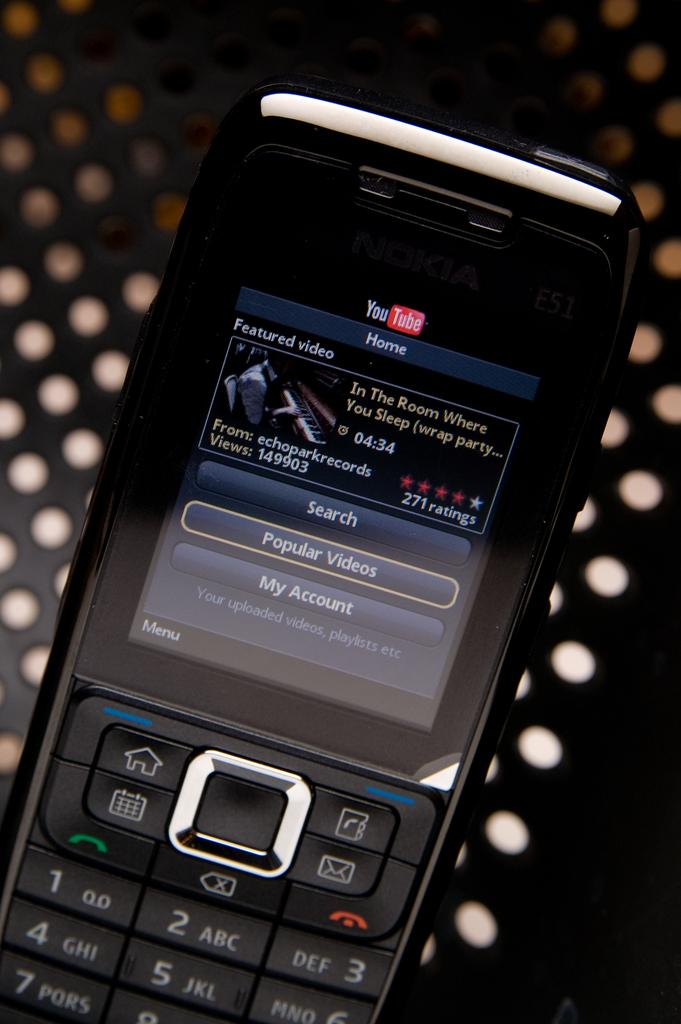<image>
Render a clear and concise summary of the photo. The YouTube site is displayed on a black cell phone. 